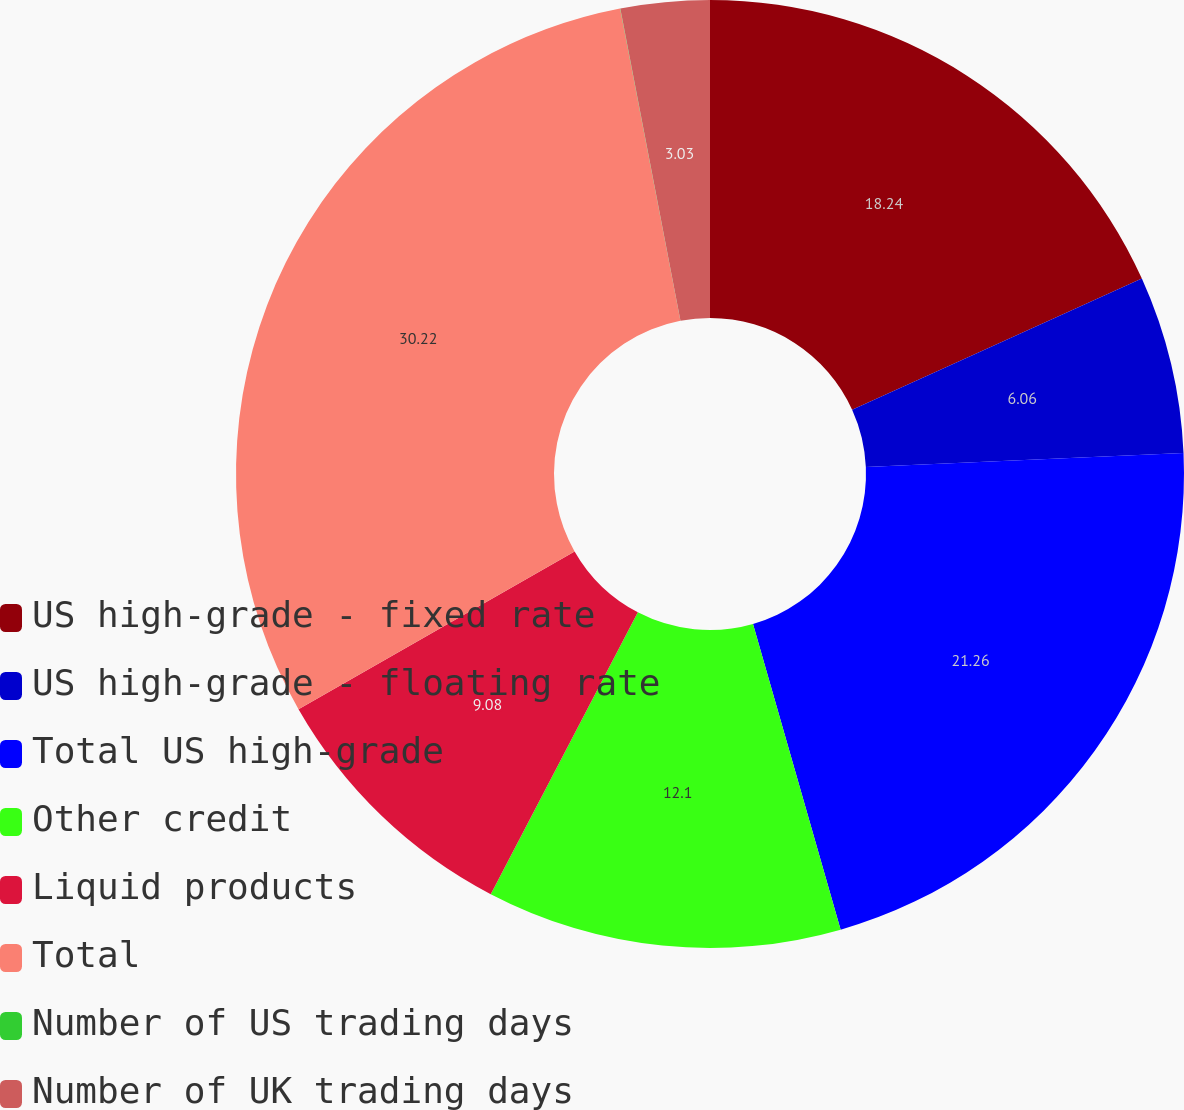Convert chart to OTSL. <chart><loc_0><loc_0><loc_500><loc_500><pie_chart><fcel>US high-grade - fixed rate<fcel>US high-grade - floating rate<fcel>Total US high-grade<fcel>Other credit<fcel>Liquid products<fcel>Total<fcel>Number of US trading days<fcel>Number of UK trading days<nl><fcel>18.24%<fcel>6.06%<fcel>21.26%<fcel>12.1%<fcel>9.08%<fcel>30.23%<fcel>0.01%<fcel>3.03%<nl></chart> 